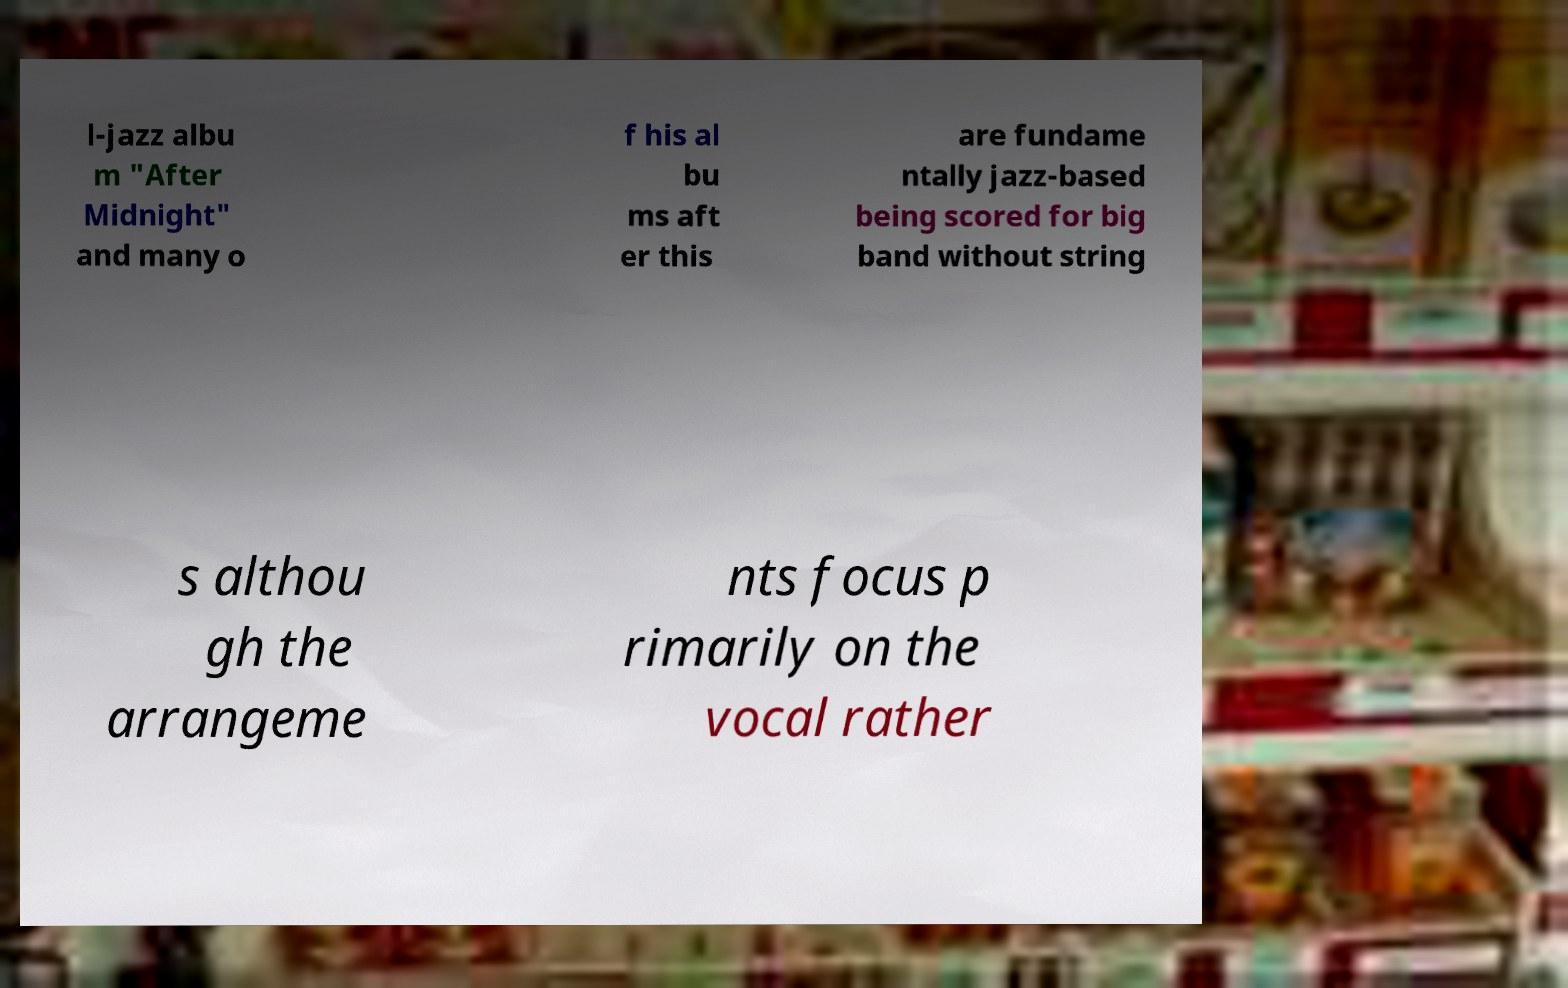What messages or text are displayed in this image? I need them in a readable, typed format. l-jazz albu m "After Midnight" and many o f his al bu ms aft er this are fundame ntally jazz-based being scored for big band without string s althou gh the arrangeme nts focus p rimarily on the vocal rather 